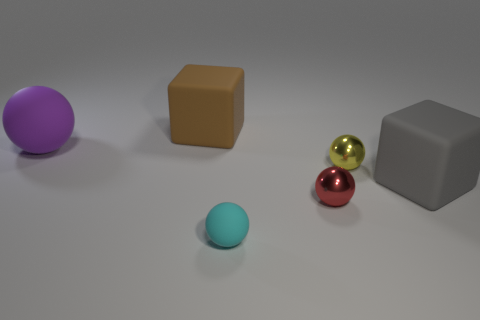Subtract all small rubber spheres. How many spheres are left? 3 Subtract 3 spheres. How many spheres are left? 1 Add 4 purple rubber things. How many objects exist? 10 Add 1 large objects. How many large objects exist? 4 Subtract all brown blocks. How many blocks are left? 1 Subtract 1 brown blocks. How many objects are left? 5 Subtract all spheres. How many objects are left? 2 Subtract all purple blocks. Subtract all purple cylinders. How many blocks are left? 2 Subtract all red blocks. How many green balls are left? 0 Subtract all tiny yellow metal things. Subtract all large rubber blocks. How many objects are left? 3 